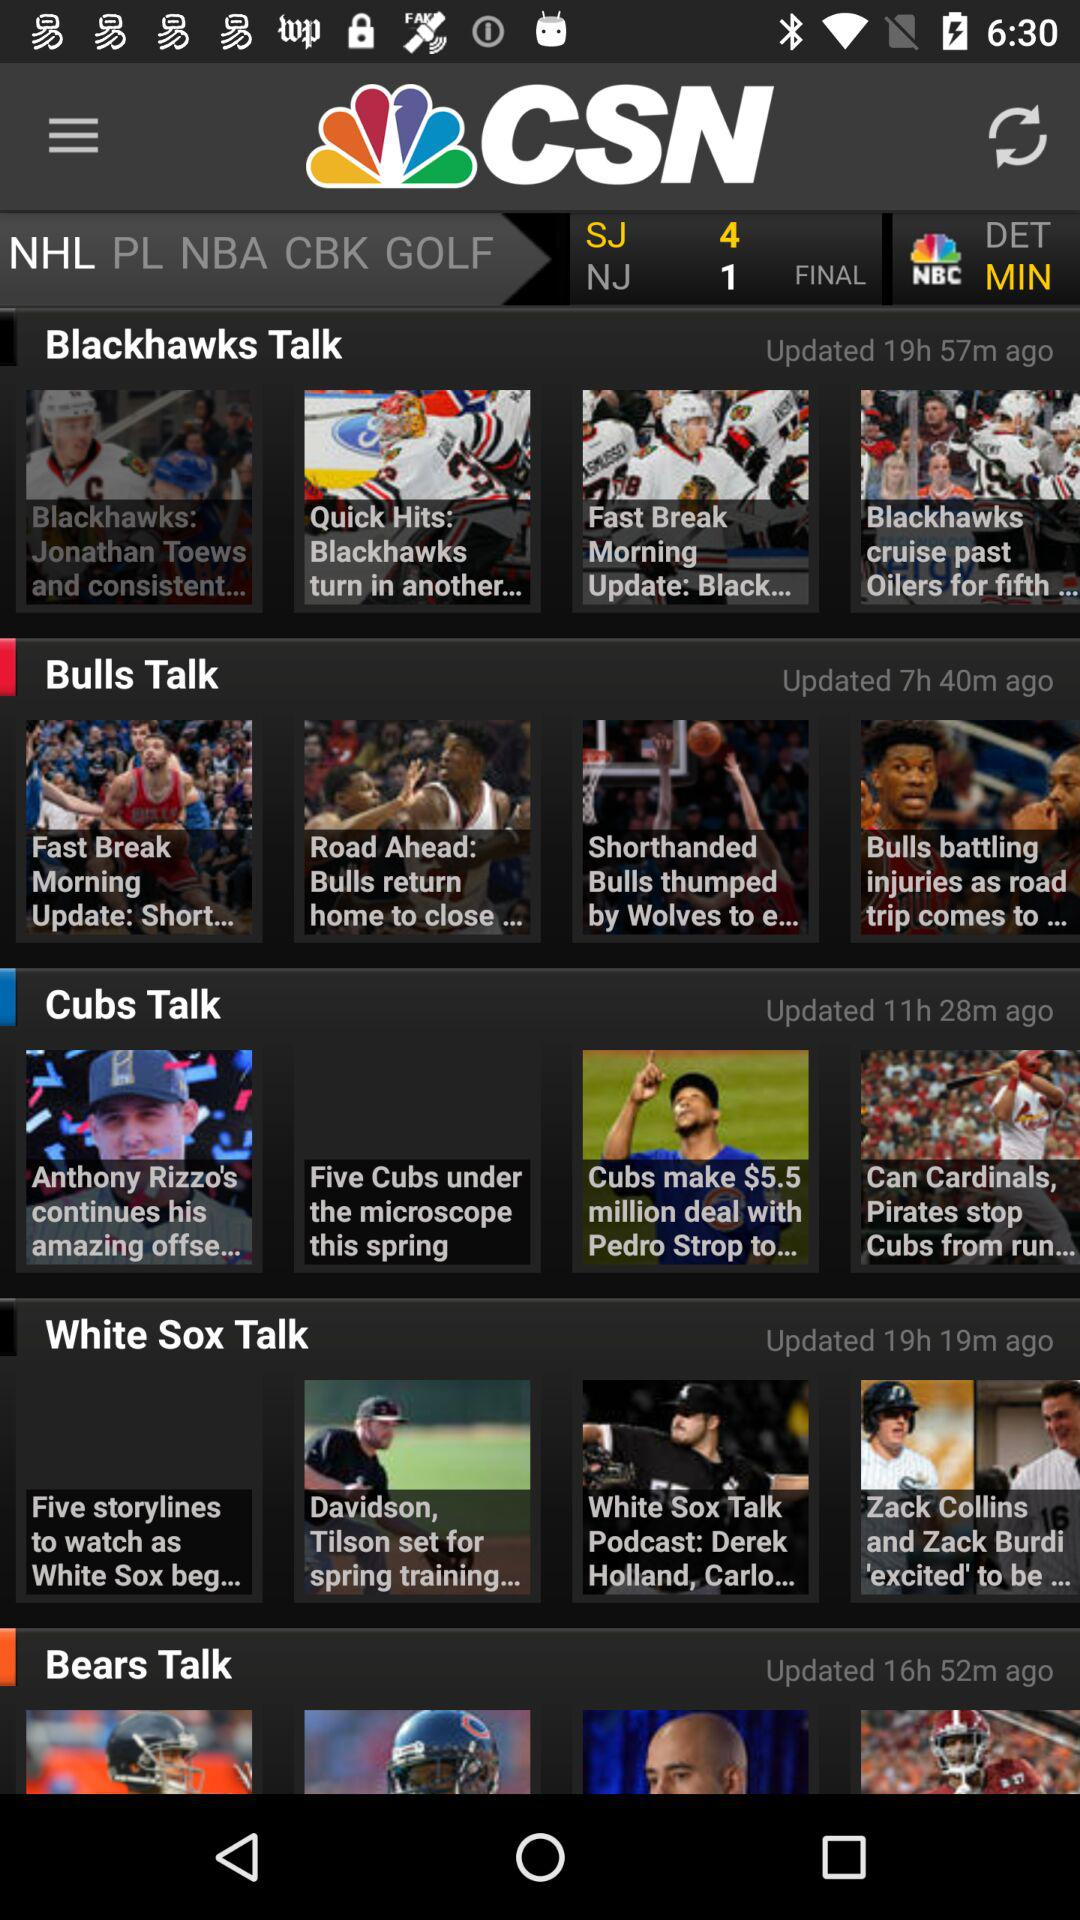Who updated the videos?
When the provided information is insufficient, respond with <no answer>. <no answer> 